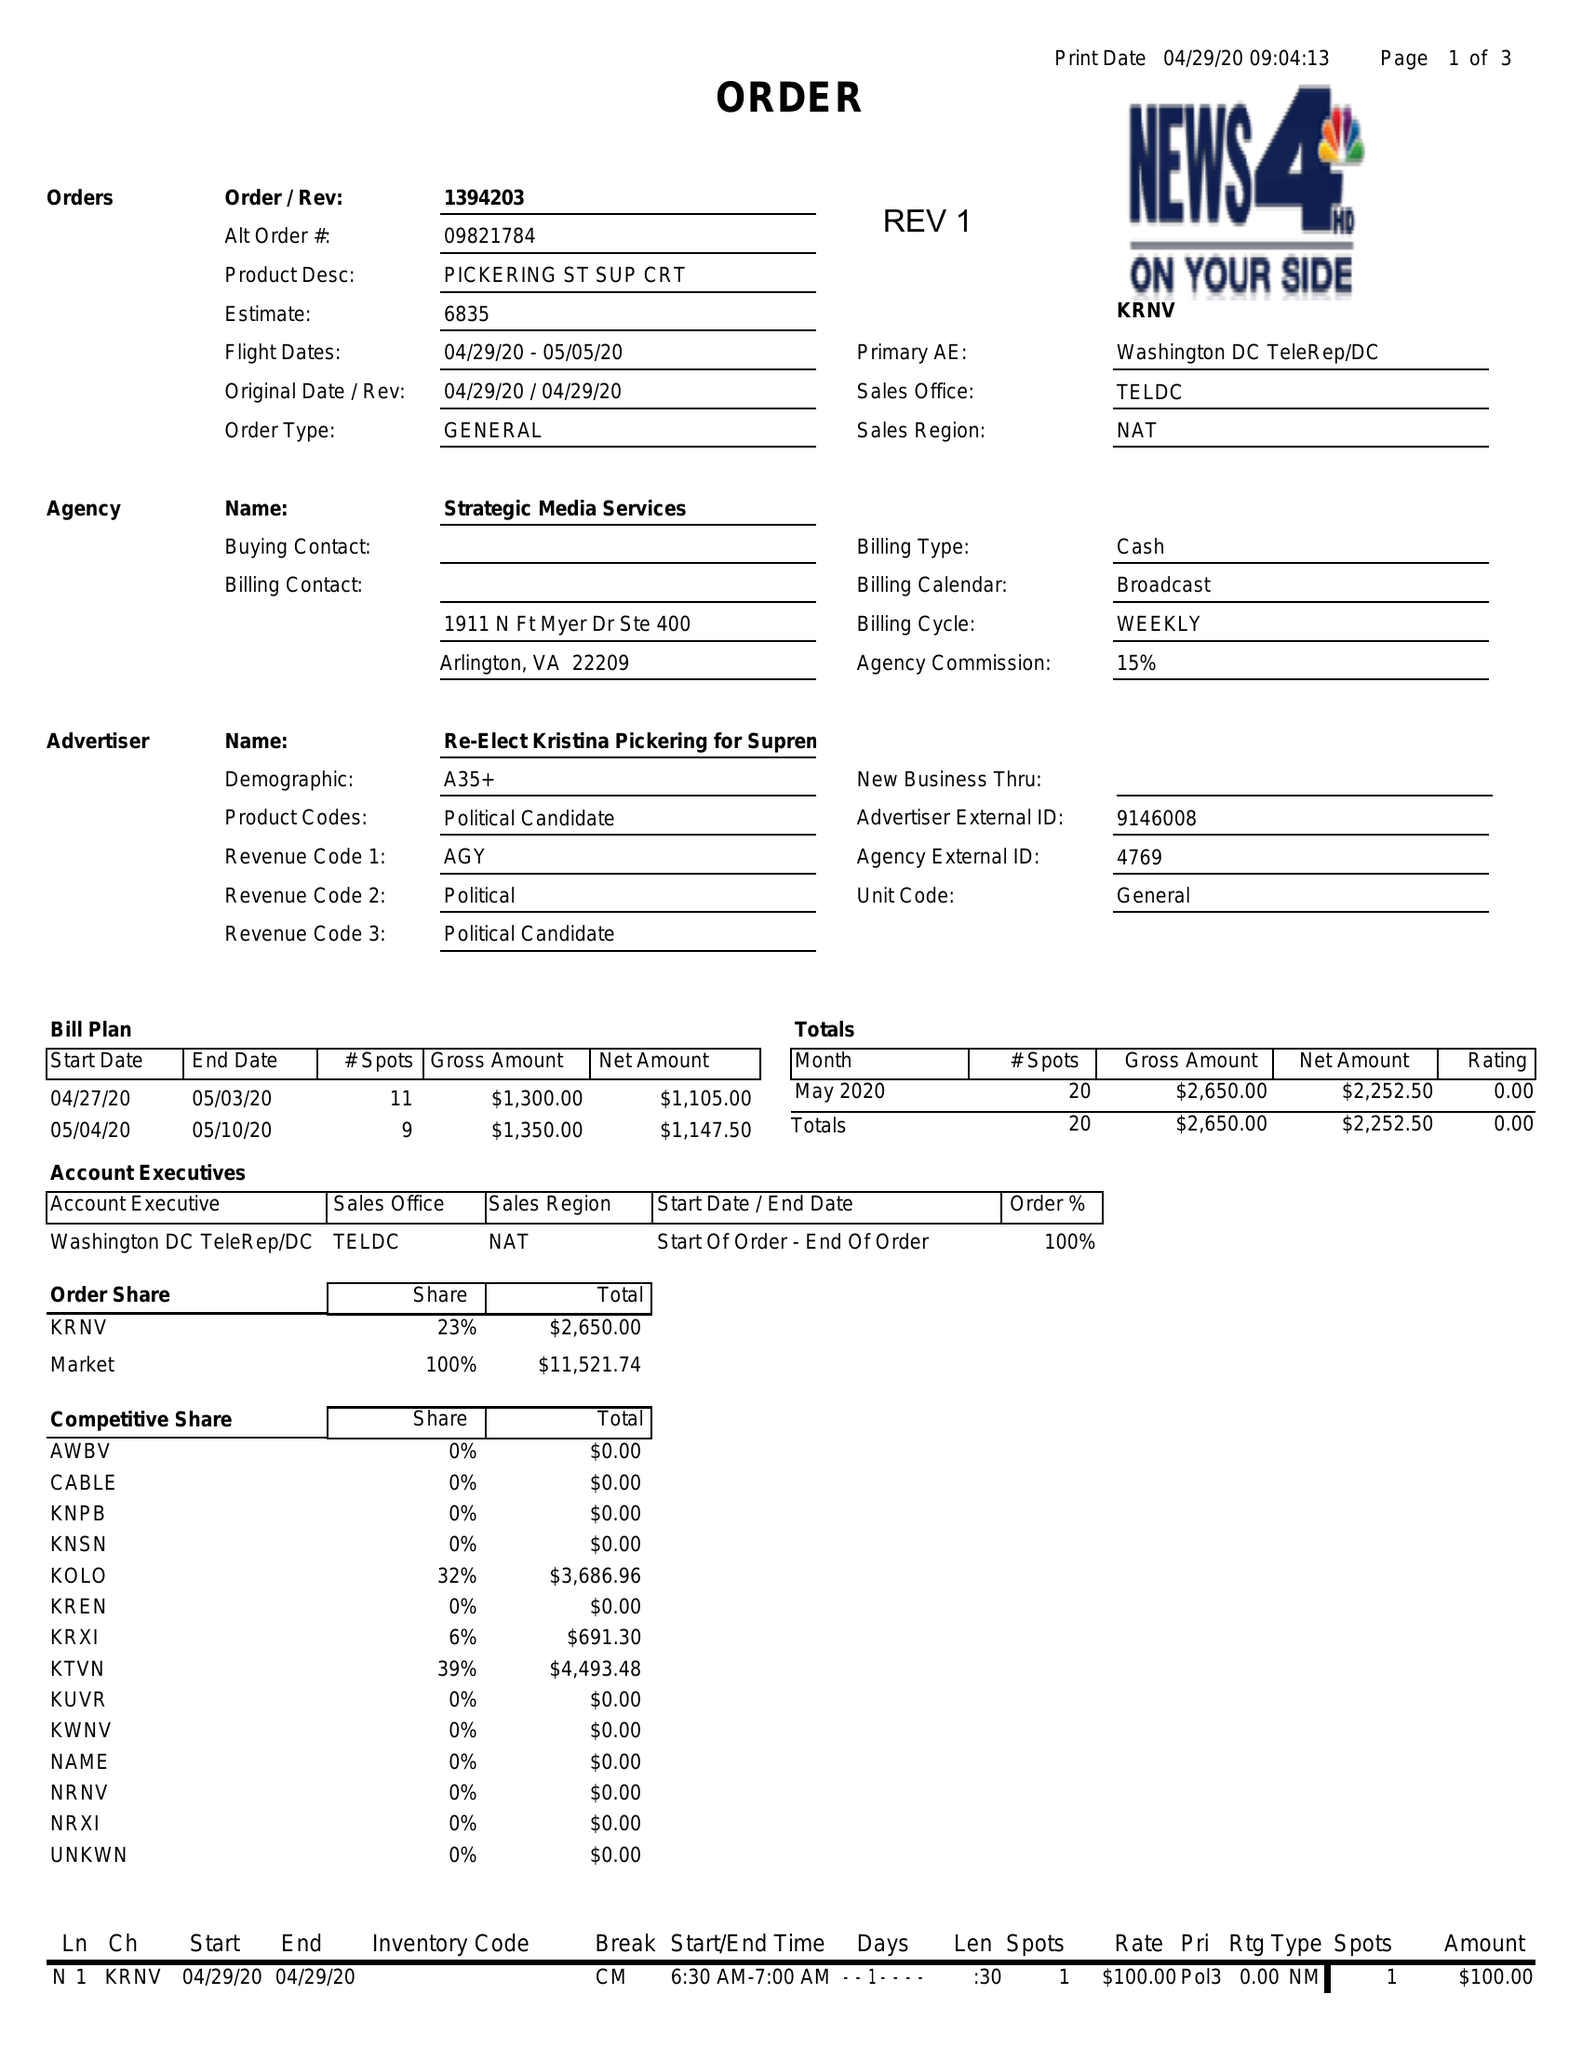What is the value for the flight_to?
Answer the question using a single word or phrase. 05/05/20 